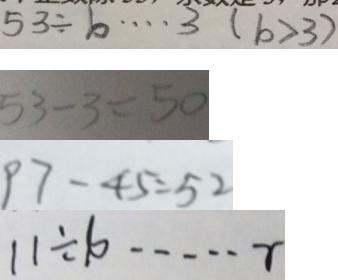Convert formula to latex. <formula><loc_0><loc_0><loc_500><loc_500>5 3 \div b \cdots 3 ( b > 3 ) 
 5 3 - 3 = 5 0 
 9 7 - 4 5 = 5 2 
 1 1 \div 1 0 \cdots r</formula> 